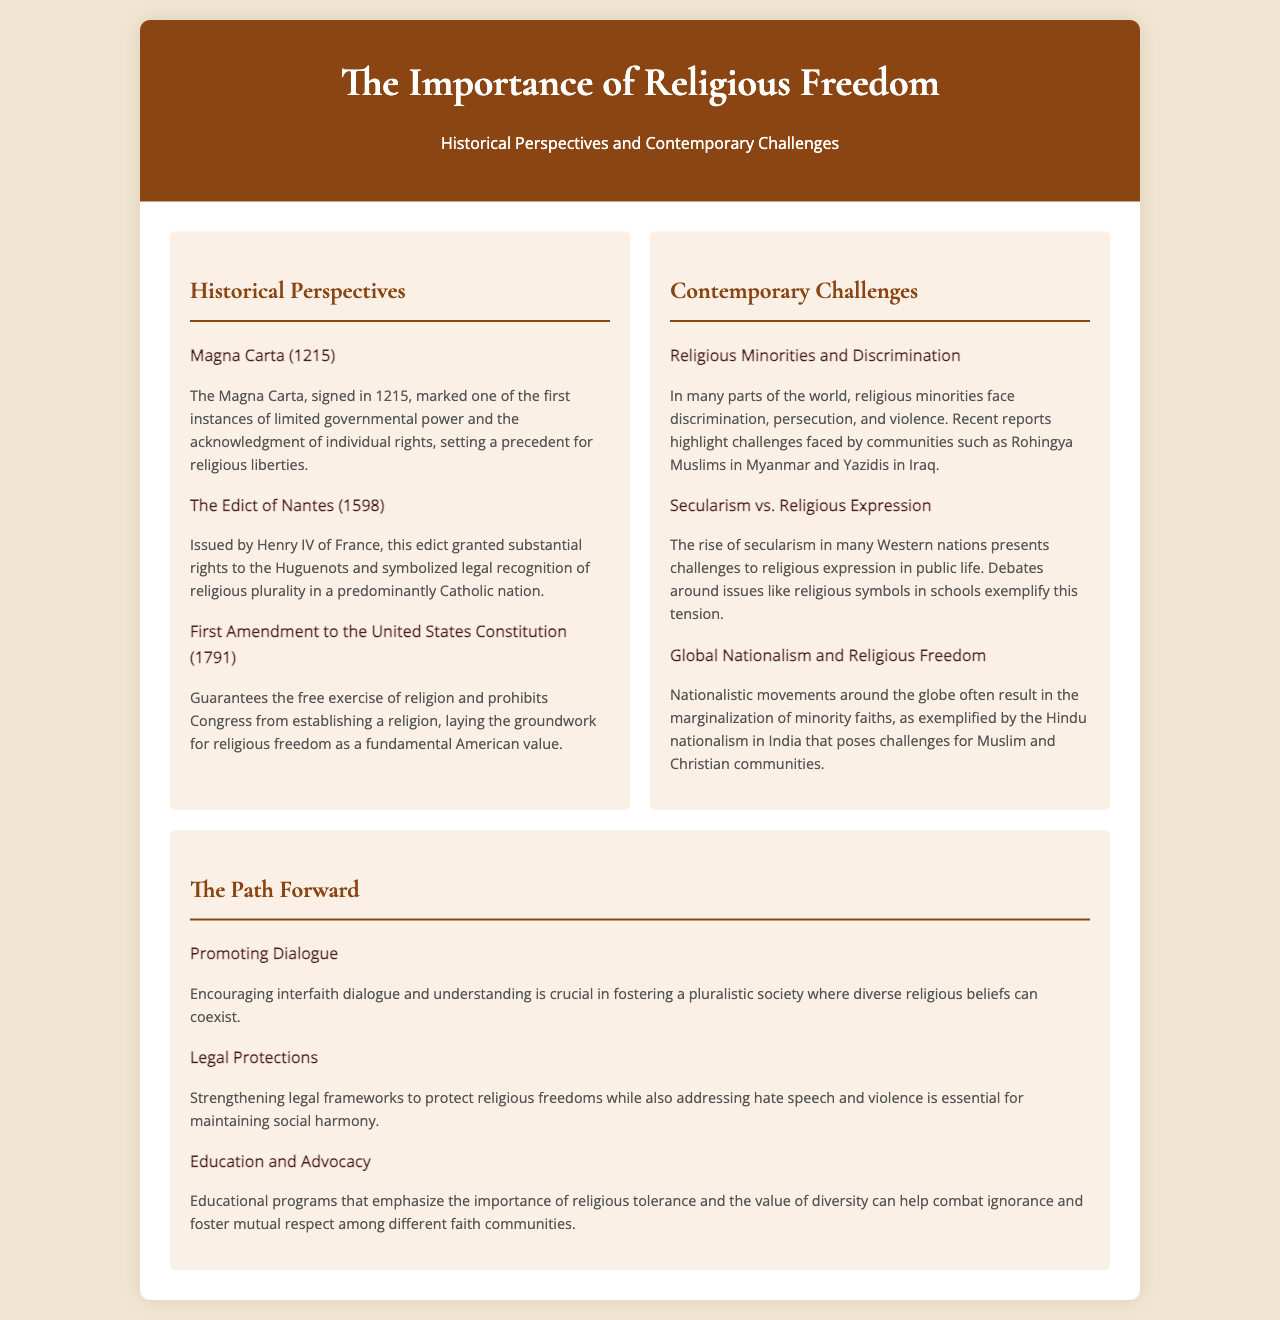what year was the Magna Carta signed? The document states that the Magna Carta was signed in 1215.
Answer: 1215 who issued the Edict of Nantes? The brochure indicates that the Edict of Nantes was issued by Henry IV of France.
Answer: Henry IV of France what does the First Amendment guarantee? According to the document, the First Amendment guarantees the free exercise of religion.
Answer: free exercise of religion which community faces challenges in Myanmar? The brochure mentions that Rohingya Muslims in Myanmar face significant challenges.
Answer: Rohingya Muslims what is a contemporary challenge related to secularism? The document discusses "Secularism vs. Religious Expression" as a contemporary challenge.
Answer: Secularism vs. Religious Expression what does the section on "The Path Forward" emphasize? The section on "The Path Forward" discusses promoting dialogue as a key element for fostering a pluralistic society.
Answer: Promoting Dialogue how does global nationalism affect religious freedom? The brochure states that global nationalism often results in the marginalization of minority faiths.
Answer: marginalization of minority faiths what can education programs help combat? The document states that educational programs can help combat ignorance.
Answer: ignorance 